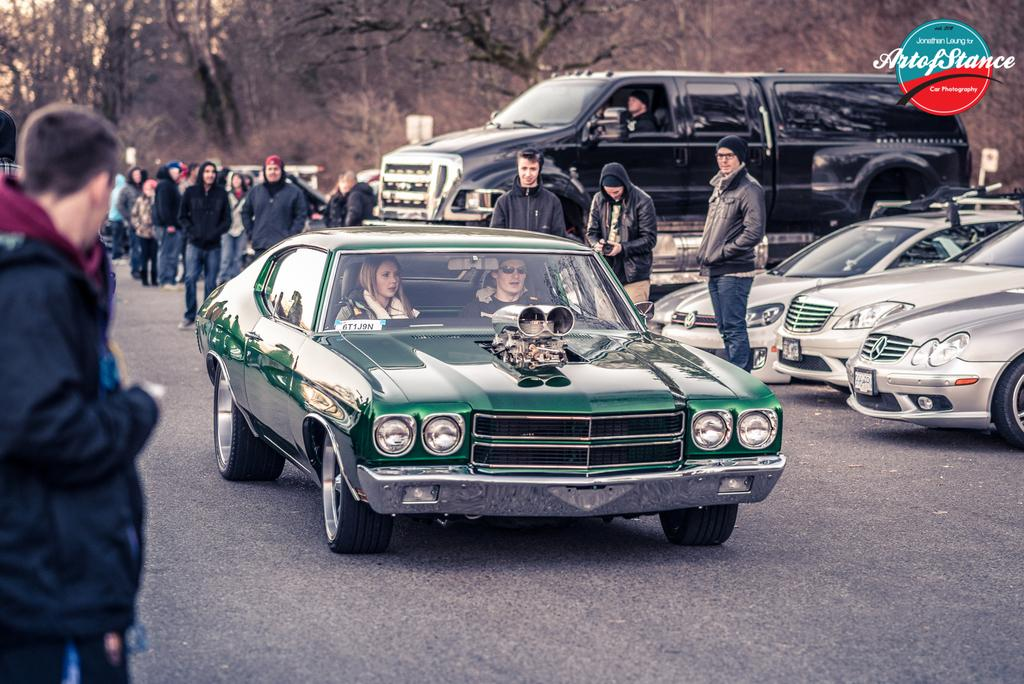What type of vegetation can be seen in the background of the image? There are bare trees in the background of the image. What are the people in the image doing? There are people walking and standing on the road. What else can be seen on the road besides people? There are vehicles on the road. What type of plate is being used to control the wind in the image? There is no plate or wind control depicted in the image. Can you describe the veins of the trees in the background? There are no veins visible in the image, as it features bare trees in the background. 